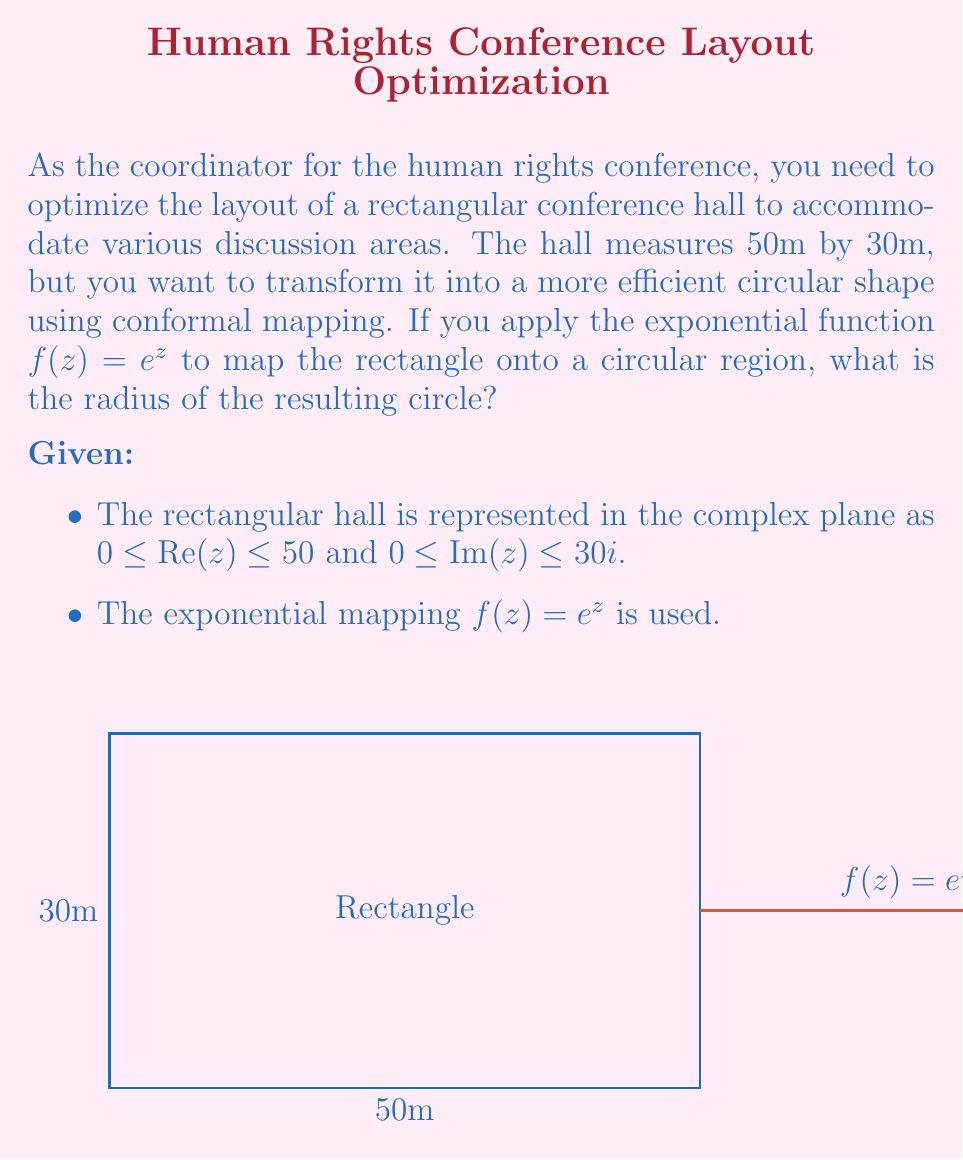Provide a solution to this math problem. Let's approach this step-by-step:

1) The exponential function maps rectangles to circular sectors. The width of the rectangle determines the angle of the sector, while the height determines the ratio of the outer to inner radius.

2) The width of our rectangle is 50, so the angle of the sector will be $50$ radians.

3) The height of our rectangle is 30, so the ratio of outer to inner radius will be $e^{30}$.

4) To find the radius of the complete circle, we need to determine how many times our sector angle (50 radians) fits into a full circle (2π radians).

5) The number of sectors needed to complete the circle is:

   $$n = \frac{2\pi}{50} \approx 0.12566$$

6) The outer radius of our sector is $e^{30}$ times the inner radius. To get a complete circle, we need to multiply this by $n$:

   $$R = r \cdot e^{30} \cdot 0.12566$$

   where $R$ is the outer radius and $r$ is the inner radius.

7) For a complete circle, the inner and outer radii must be the same, so:

   $$R = R \cdot e^{30} \cdot 0.12566$$

8) Solving for $R$:

   $$1 = e^{30} \cdot 0.12566$$
   $$R = \frac{1}{0.12566 \cdot e^{30}} \approx 5.2491 \times 10^{-14}$$
Answer: $5.2491 \times 10^{-14}$ meters 